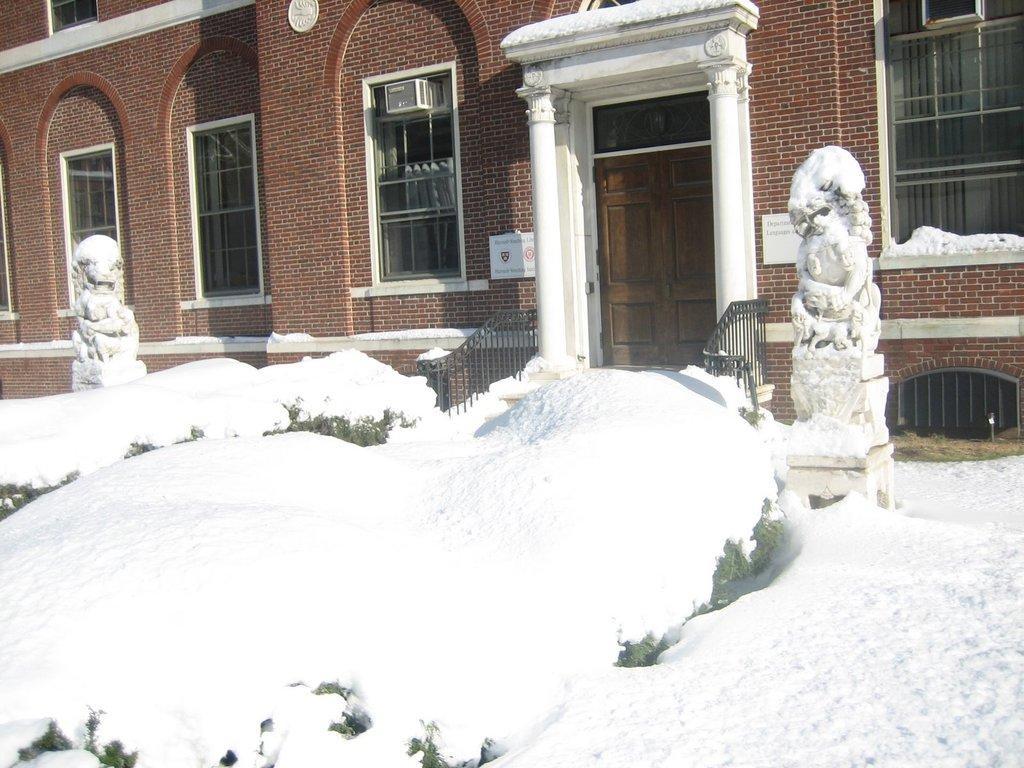In one or two sentences, can you explain what this image depicts? In the image we can see the building and these are the windows of the building. Here we can see the door and the fence. Here we can see the snow, white in color and the sculptures. 